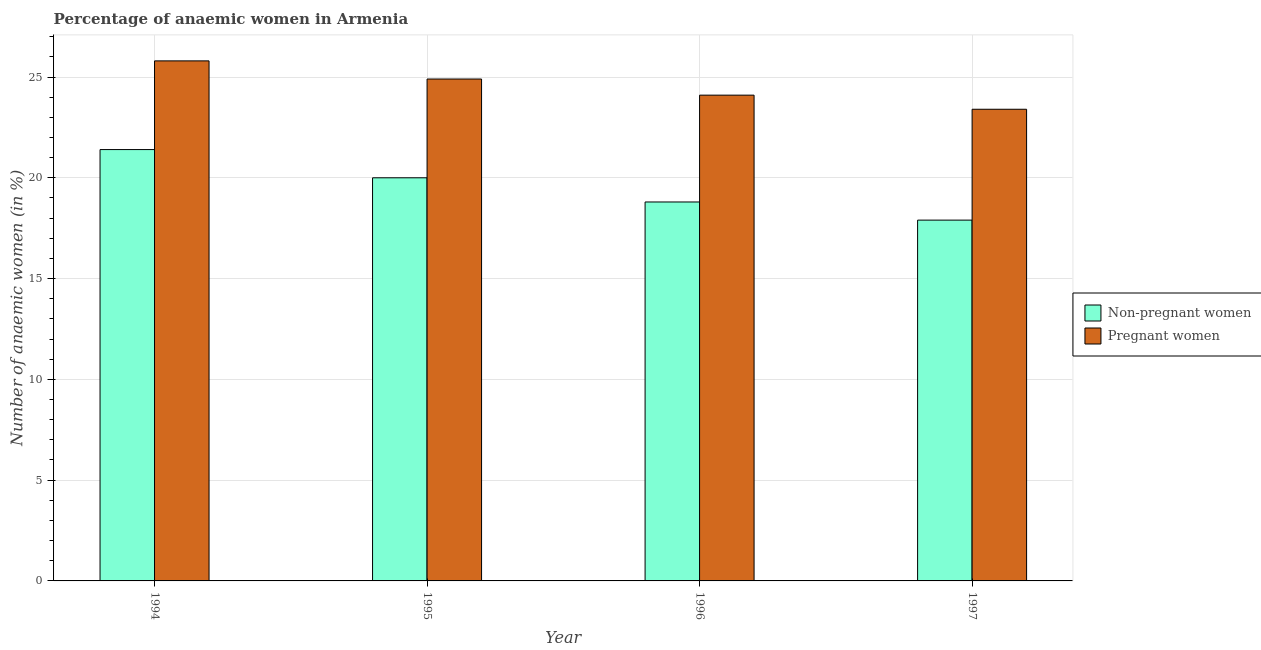How many different coloured bars are there?
Give a very brief answer. 2. How many groups of bars are there?
Provide a succinct answer. 4. What is the label of the 2nd group of bars from the left?
Give a very brief answer. 1995. What is the percentage of pregnant anaemic women in 1996?
Provide a succinct answer. 24.1. Across all years, what is the maximum percentage of non-pregnant anaemic women?
Ensure brevity in your answer.  21.4. Across all years, what is the minimum percentage of pregnant anaemic women?
Offer a terse response. 23.4. In which year was the percentage of non-pregnant anaemic women maximum?
Give a very brief answer. 1994. What is the total percentage of pregnant anaemic women in the graph?
Make the answer very short. 98.2. What is the difference between the percentage of non-pregnant anaemic women in 1994 and that in 1997?
Make the answer very short. 3.5. What is the difference between the percentage of pregnant anaemic women in 1997 and the percentage of non-pregnant anaemic women in 1994?
Offer a terse response. -2.4. What is the average percentage of pregnant anaemic women per year?
Provide a short and direct response. 24.55. In the year 1996, what is the difference between the percentage of non-pregnant anaemic women and percentage of pregnant anaemic women?
Give a very brief answer. 0. What is the ratio of the percentage of non-pregnant anaemic women in 1995 to that in 1996?
Ensure brevity in your answer.  1.06. What is the difference between the highest and the second highest percentage of pregnant anaemic women?
Your answer should be compact. 0.9. In how many years, is the percentage of non-pregnant anaemic women greater than the average percentage of non-pregnant anaemic women taken over all years?
Ensure brevity in your answer.  2. Is the sum of the percentage of pregnant anaemic women in 1995 and 1996 greater than the maximum percentage of non-pregnant anaemic women across all years?
Offer a terse response. Yes. What does the 1st bar from the left in 1994 represents?
Offer a very short reply. Non-pregnant women. What does the 1st bar from the right in 1996 represents?
Give a very brief answer. Pregnant women. How many bars are there?
Your response must be concise. 8. Are all the bars in the graph horizontal?
Ensure brevity in your answer.  No. How many years are there in the graph?
Provide a succinct answer. 4. Does the graph contain any zero values?
Give a very brief answer. No. Where does the legend appear in the graph?
Your response must be concise. Center right. How are the legend labels stacked?
Ensure brevity in your answer.  Vertical. What is the title of the graph?
Your answer should be very brief. Percentage of anaemic women in Armenia. What is the label or title of the Y-axis?
Keep it short and to the point. Number of anaemic women (in %). What is the Number of anaemic women (in %) in Non-pregnant women in 1994?
Your response must be concise. 21.4. What is the Number of anaemic women (in %) of Pregnant women in 1994?
Your answer should be very brief. 25.8. What is the Number of anaemic women (in %) in Pregnant women in 1995?
Make the answer very short. 24.9. What is the Number of anaemic women (in %) in Pregnant women in 1996?
Provide a short and direct response. 24.1. What is the Number of anaemic women (in %) of Pregnant women in 1997?
Ensure brevity in your answer.  23.4. Across all years, what is the maximum Number of anaemic women (in %) in Non-pregnant women?
Give a very brief answer. 21.4. Across all years, what is the maximum Number of anaemic women (in %) in Pregnant women?
Your response must be concise. 25.8. Across all years, what is the minimum Number of anaemic women (in %) of Pregnant women?
Offer a very short reply. 23.4. What is the total Number of anaemic women (in %) in Non-pregnant women in the graph?
Your answer should be very brief. 78.1. What is the total Number of anaemic women (in %) in Pregnant women in the graph?
Give a very brief answer. 98.2. What is the difference between the Number of anaemic women (in %) in Pregnant women in 1994 and that in 1995?
Offer a very short reply. 0.9. What is the difference between the Number of anaemic women (in %) of Non-pregnant women in 1994 and that in 1997?
Your answer should be compact. 3.5. What is the difference between the Number of anaemic women (in %) of Pregnant women in 1994 and that in 1997?
Ensure brevity in your answer.  2.4. What is the difference between the Number of anaemic women (in %) of Non-pregnant women in 1995 and that in 1996?
Ensure brevity in your answer.  1.2. What is the difference between the Number of anaemic women (in %) of Non-pregnant women in 1995 and that in 1997?
Your response must be concise. 2.1. What is the difference between the Number of anaemic women (in %) of Non-pregnant women in 1994 and the Number of anaemic women (in %) of Pregnant women in 1996?
Give a very brief answer. -2.7. What is the difference between the Number of anaemic women (in %) of Non-pregnant women in 1995 and the Number of anaemic women (in %) of Pregnant women in 1996?
Ensure brevity in your answer.  -4.1. What is the difference between the Number of anaemic women (in %) in Non-pregnant women in 1996 and the Number of anaemic women (in %) in Pregnant women in 1997?
Provide a succinct answer. -4.6. What is the average Number of anaemic women (in %) of Non-pregnant women per year?
Offer a terse response. 19.52. What is the average Number of anaemic women (in %) of Pregnant women per year?
Provide a short and direct response. 24.55. In the year 1995, what is the difference between the Number of anaemic women (in %) of Non-pregnant women and Number of anaemic women (in %) of Pregnant women?
Offer a very short reply. -4.9. What is the ratio of the Number of anaemic women (in %) of Non-pregnant women in 1994 to that in 1995?
Keep it short and to the point. 1.07. What is the ratio of the Number of anaemic women (in %) in Pregnant women in 1994 to that in 1995?
Your response must be concise. 1.04. What is the ratio of the Number of anaemic women (in %) in Non-pregnant women in 1994 to that in 1996?
Make the answer very short. 1.14. What is the ratio of the Number of anaemic women (in %) of Pregnant women in 1994 to that in 1996?
Provide a short and direct response. 1.07. What is the ratio of the Number of anaemic women (in %) of Non-pregnant women in 1994 to that in 1997?
Your response must be concise. 1.2. What is the ratio of the Number of anaemic women (in %) of Pregnant women in 1994 to that in 1997?
Ensure brevity in your answer.  1.1. What is the ratio of the Number of anaemic women (in %) of Non-pregnant women in 1995 to that in 1996?
Your response must be concise. 1.06. What is the ratio of the Number of anaemic women (in %) of Pregnant women in 1995 to that in 1996?
Keep it short and to the point. 1.03. What is the ratio of the Number of anaemic women (in %) in Non-pregnant women in 1995 to that in 1997?
Provide a succinct answer. 1.12. What is the ratio of the Number of anaemic women (in %) of Pregnant women in 1995 to that in 1997?
Provide a succinct answer. 1.06. What is the ratio of the Number of anaemic women (in %) of Non-pregnant women in 1996 to that in 1997?
Your answer should be compact. 1.05. What is the ratio of the Number of anaemic women (in %) in Pregnant women in 1996 to that in 1997?
Your answer should be very brief. 1.03. What is the difference between the highest and the lowest Number of anaemic women (in %) of Non-pregnant women?
Your answer should be very brief. 3.5. 